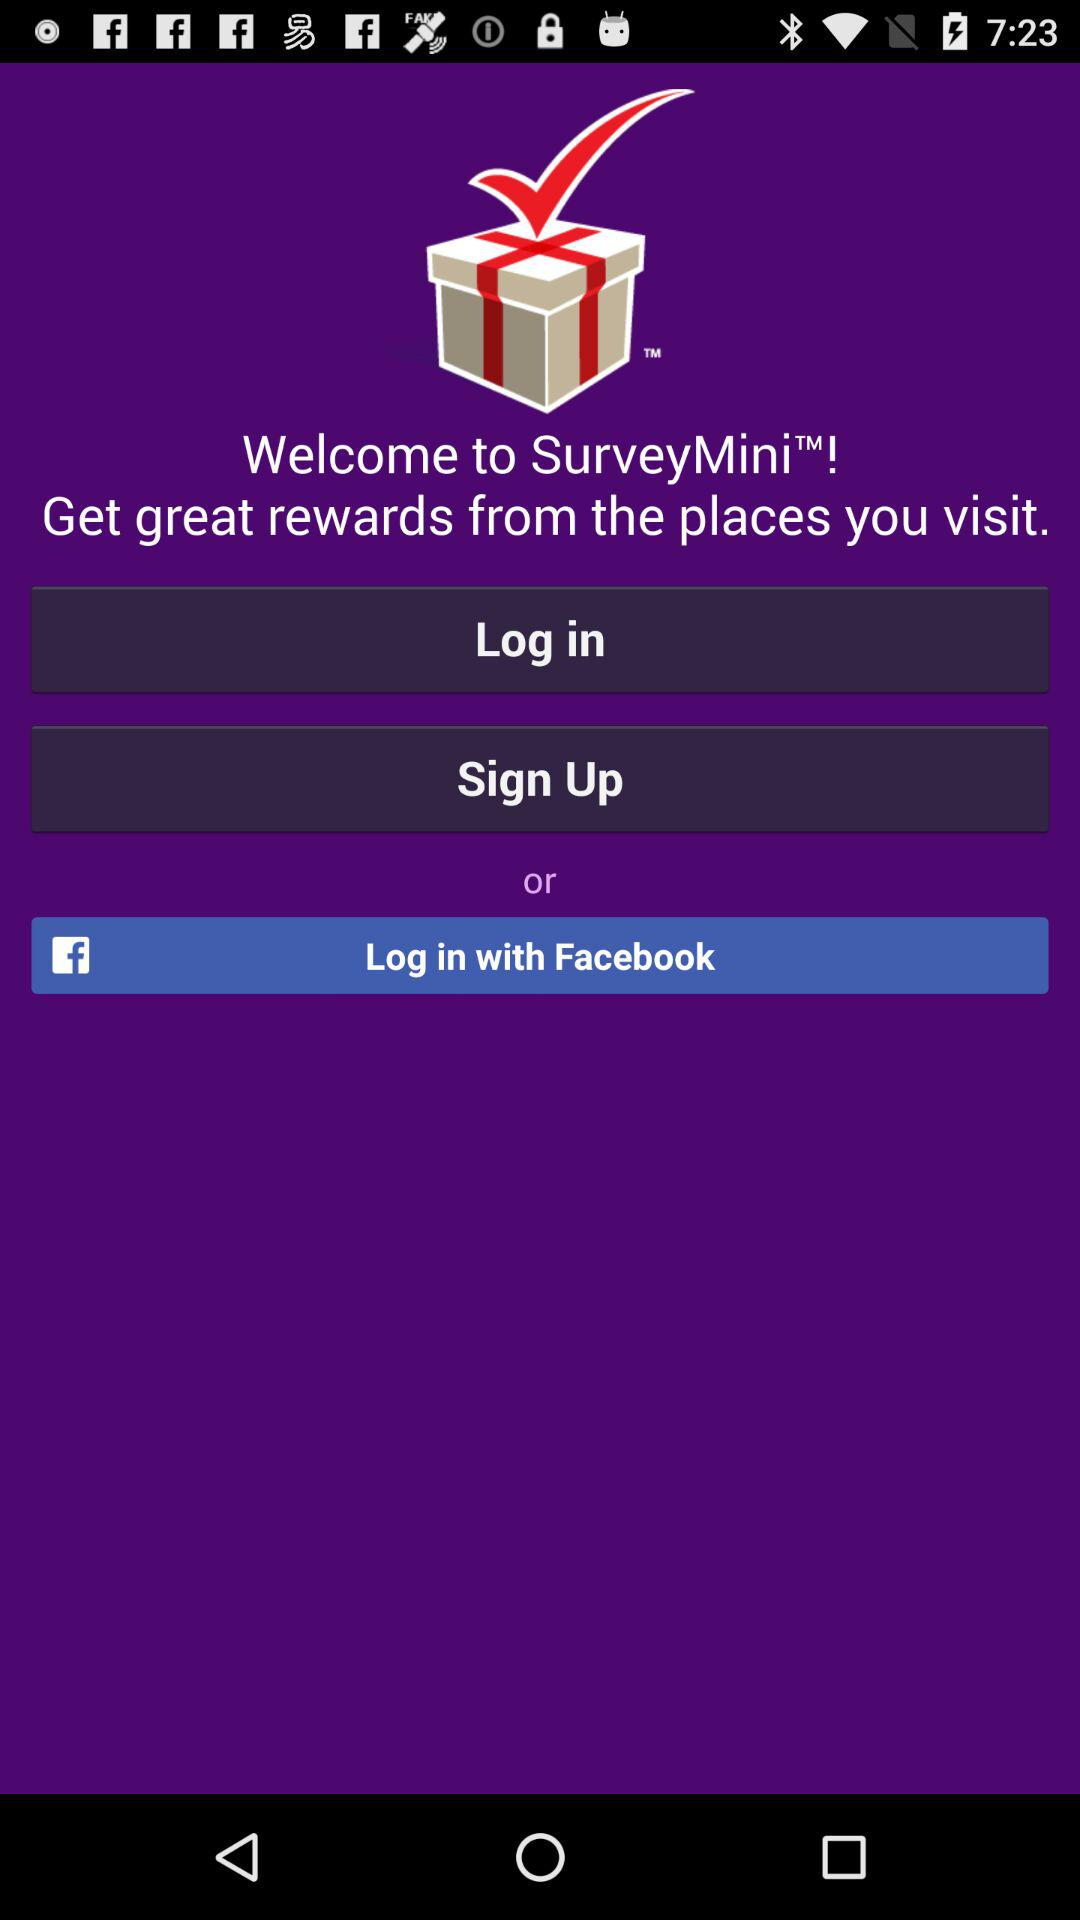What application can be used to log in? The application is "Facebook". 